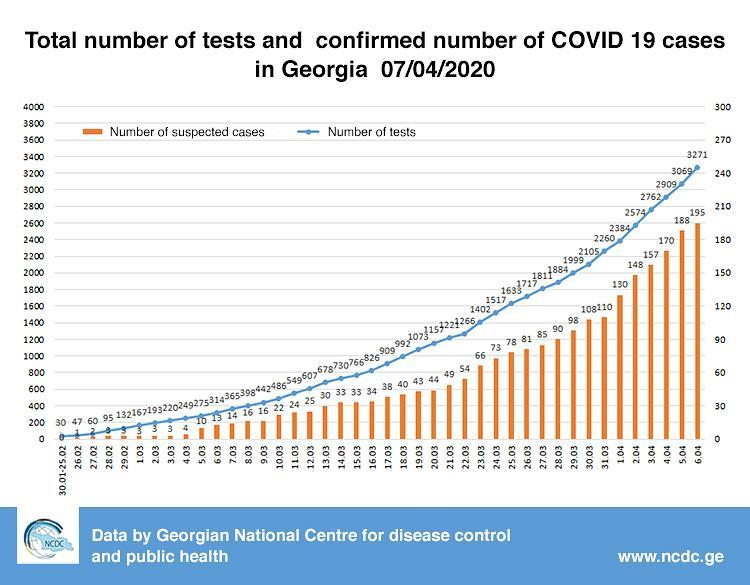What is the number of COVID-19 tests performed in Georgia as on 04/04/2020?
Answer the question with a short phrase. 2909 What is the number of suspected COVID-19 cases reported in Georgia as on 10/03/2020? 22 What is the number of COVID-19 tests performed in Georgia as on 05/04/2020? 3069 What is the number of suspected COVID-19 cases reported in Georgia as on 16/03/2020? 34 What is the number of suspected COVID-19 cases reported in Georgia as on 22/03/2020? 54 